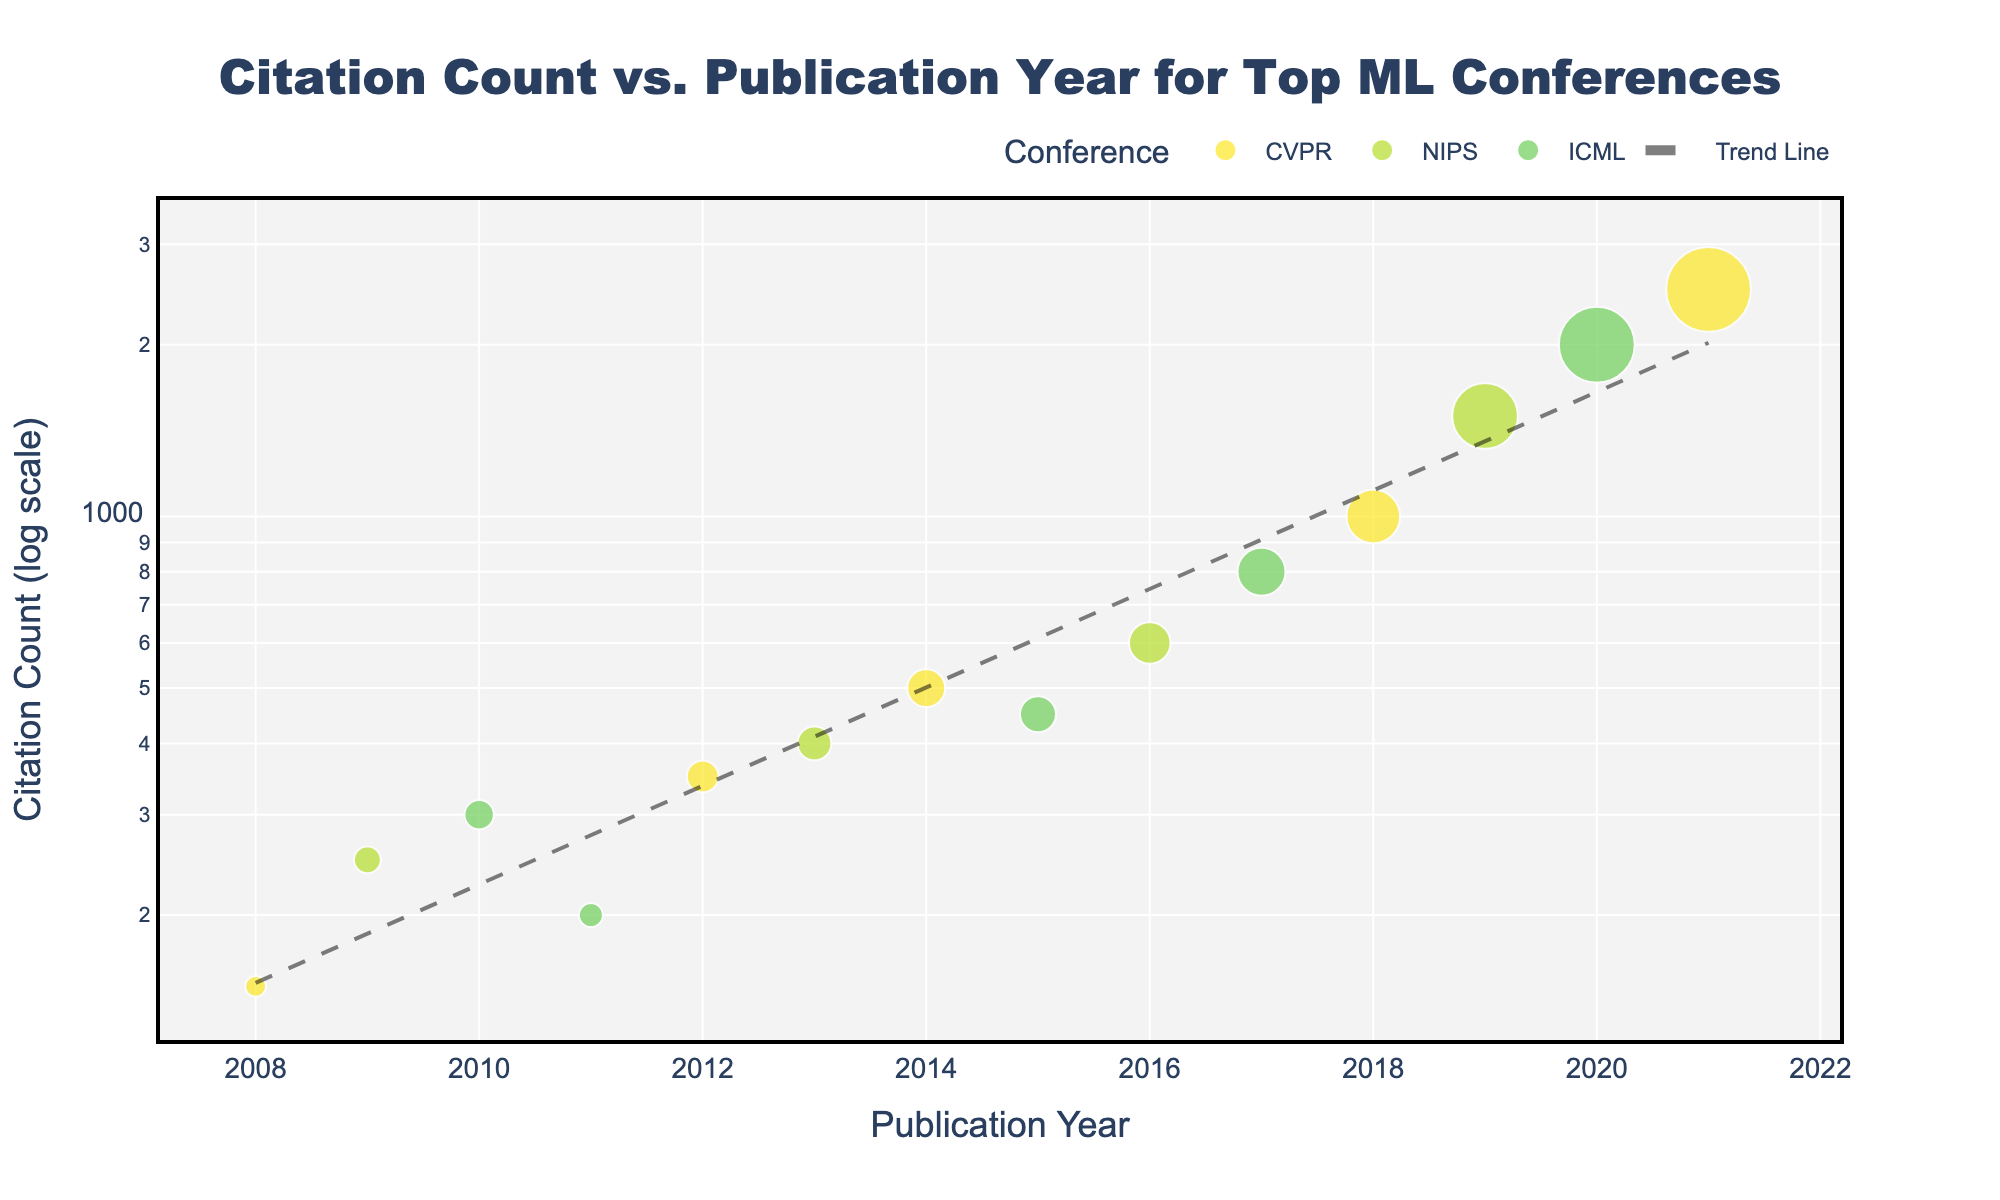what is the title of the figure? The title of the figure is usually placed at the top of the plot and is clearly indicated in the layout of the figure.
Answer: Citation Count vs. Publication Year for Top ML Conferences Which conference had the paper with the highest citation count in 2021? Analyze the plot for the data point that has 2021 on the x-axis and check the corresponding color and hover information.
Answer: CVPR Describe the trend of citation counts over publication years. Observe the general direction of the data points on the scatter plot and the trend line that has been added. The citation count tends to increase over time.
Answer: Increasing Compare the citation counts for CVPR and NIPS papers in 2008 and 2009. Which one had higher citation counts? Identify the data points for 2008 and 2009, and compare the sizes of the points for CVPR and NIPS.
Answer: NIPS in 2009 What is the smallest citation count and which year and conference does it belong to? Find the smallest point in terms of size, hover over it to see the citation count, year, and conference.
Answer: 150, 2008, CVPR How many papers have citation counts greater than 1000? Count the number of data points that are above the y-axis value of 1000.
Answer: 4 Which conference witnessed the largest increase in citation count over consecutive years? Calculate the differences in citation counts for data points of each conference that appear in consecutive years and identify the largest increase.
Answer: CVPR (2018 to 2021) If you were to visually approximate the slope of the trend line, would it be positive, negative, or neutral? Look at the trend line's direction; a stretching line from lower left to upper right indicates a positive slope.
Answer: Positive What can be inferred about the popularity of machine learning conferences over time from the citation counts? Consider the increasing trend of citations over the years, which suggests growing prominence and interest in research from these conferences.
Answer: Increasing popularity 